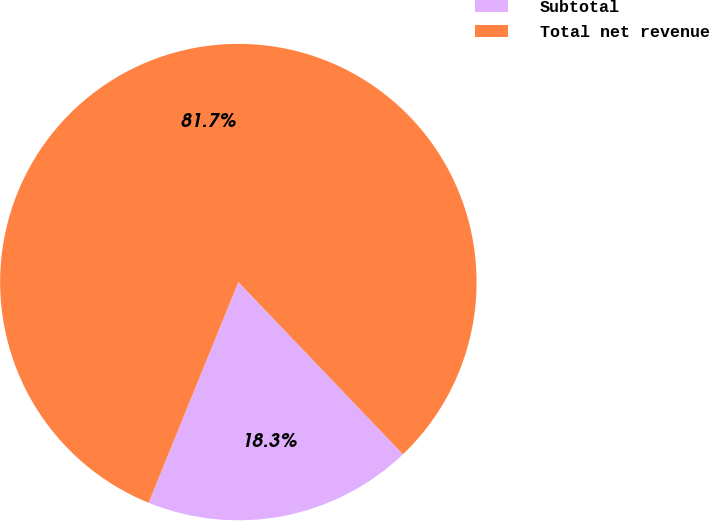Convert chart. <chart><loc_0><loc_0><loc_500><loc_500><pie_chart><fcel>Subtotal<fcel>Total net revenue<nl><fcel>18.29%<fcel>81.71%<nl></chart> 